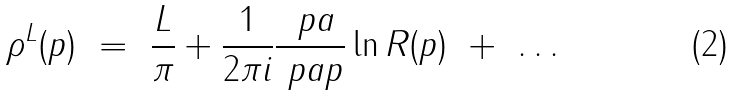<formula> <loc_0><loc_0><loc_500><loc_500>\rho ^ { L } ( p ) \ = \ \frac { L } { \pi } + \frac { 1 } { 2 \pi i } \frac { \ p a } { \ p a p } \ln R ( p ) \ + \ \dots \ \</formula> 